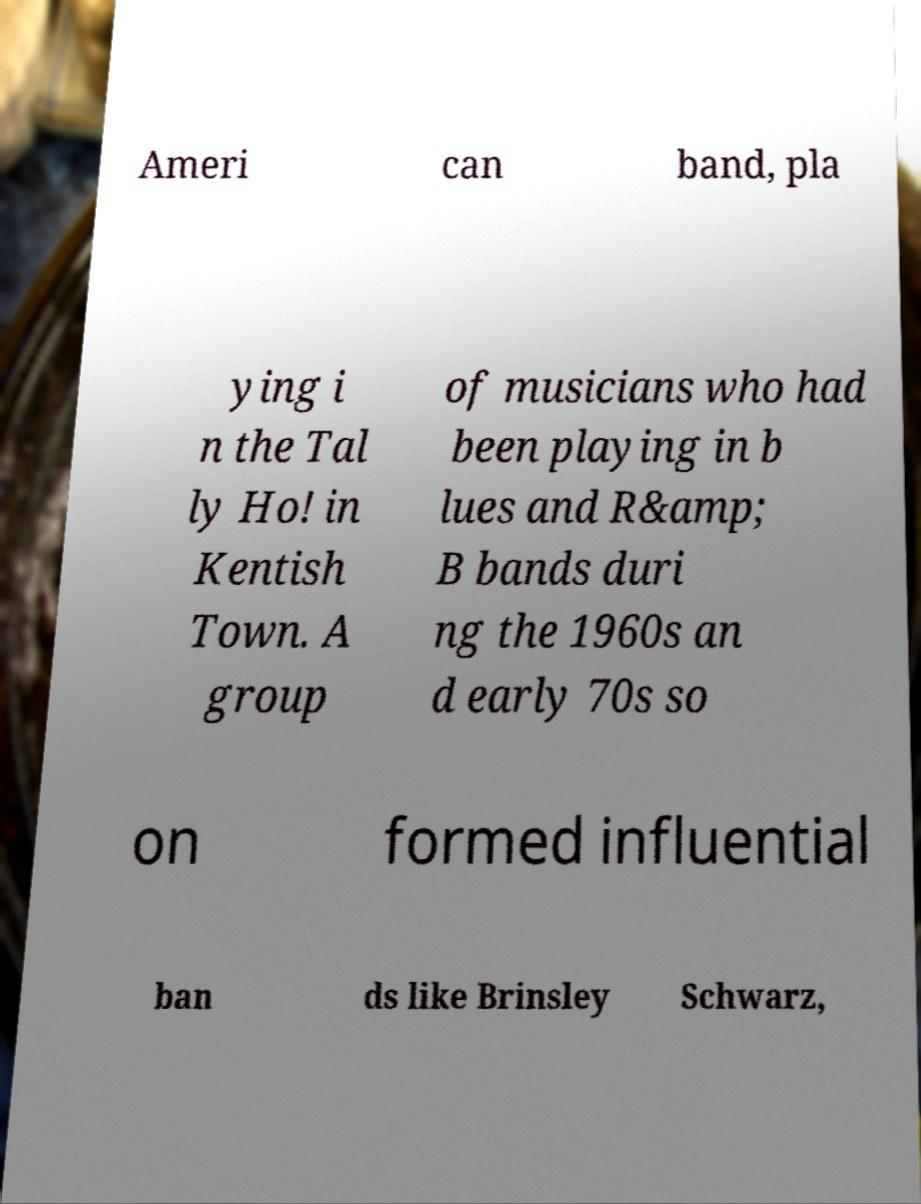For documentation purposes, I need the text within this image transcribed. Could you provide that? Ameri can band, pla ying i n the Tal ly Ho! in Kentish Town. A group of musicians who had been playing in b lues and R&amp; B bands duri ng the 1960s an d early 70s so on formed influential ban ds like Brinsley Schwarz, 